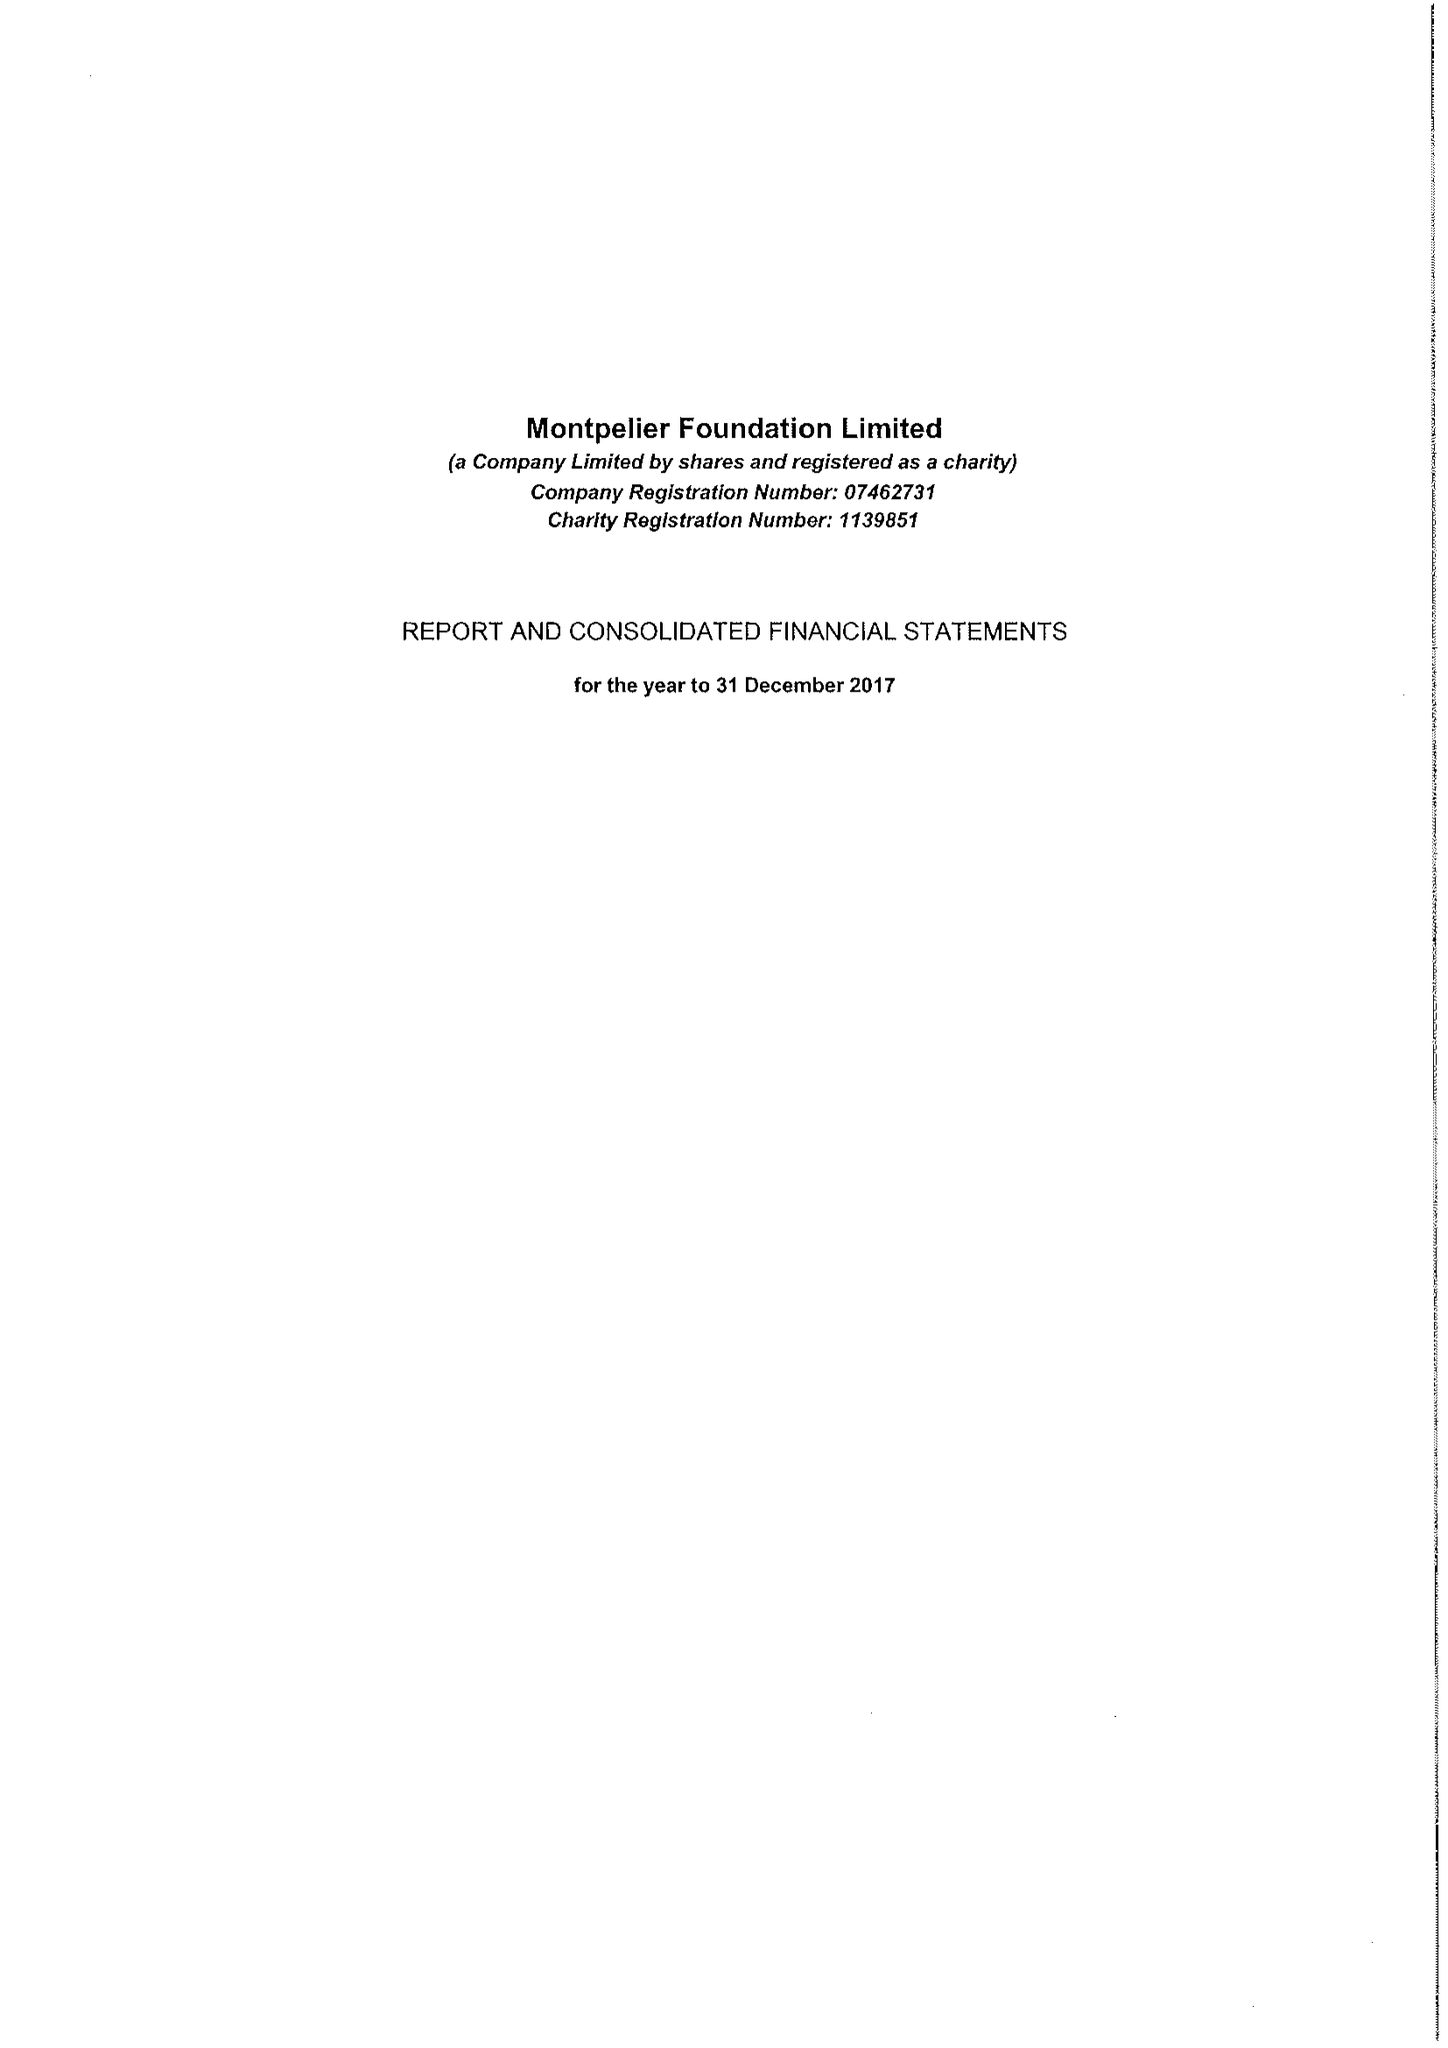What is the value for the report_date?
Answer the question using a single word or phrase. 2017-12-31 